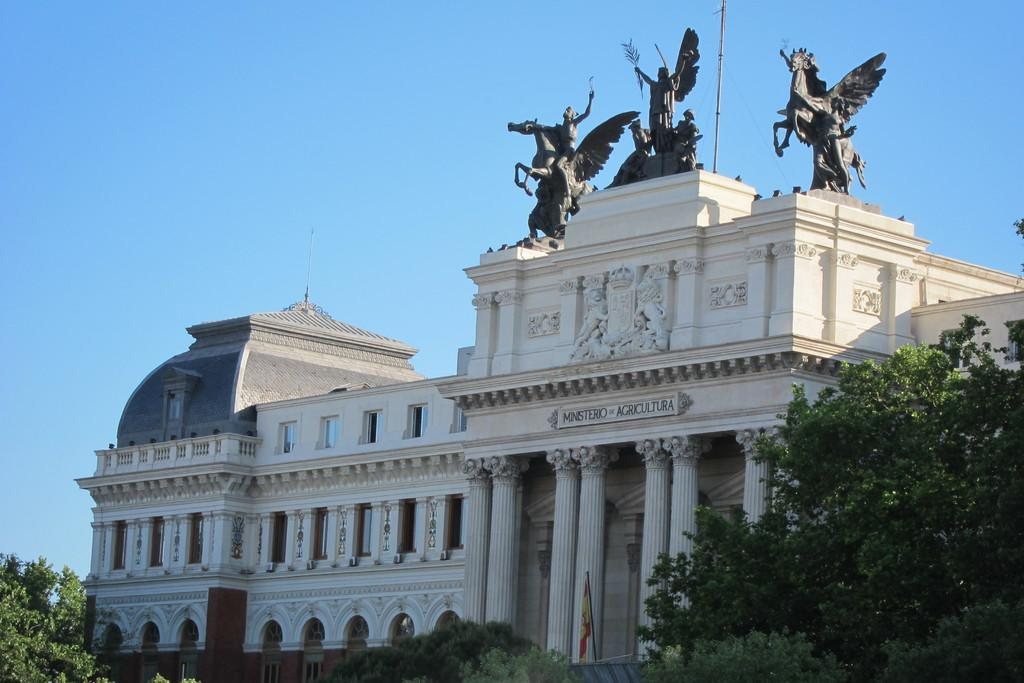What type of structure is present in the image? There is a building in the image. What can be seen at the bottom of the image? There are trees at the bottom of the image. Are there any other objects or figures in the image besides the building and trees? Yes, there are statues in the image. What is visible at the top of the image? The sky is visible at the top of the image. What type of veil is draped over the building in the image? There is no veil present in the image; it is a building with trees, statues, and a visible sky. 